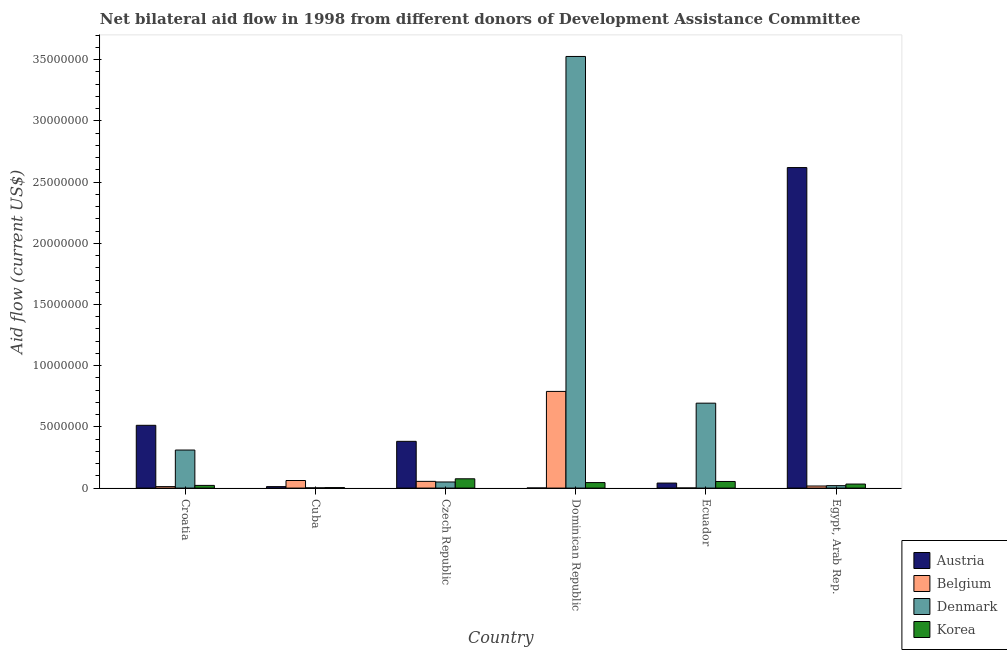Are the number of bars per tick equal to the number of legend labels?
Give a very brief answer. Yes. Are the number of bars on each tick of the X-axis equal?
Offer a very short reply. Yes. What is the label of the 2nd group of bars from the left?
Keep it short and to the point. Cuba. In how many cases, is the number of bars for a given country not equal to the number of legend labels?
Provide a succinct answer. 0. What is the amount of aid given by korea in Egypt, Arab Rep.?
Provide a short and direct response. 3.30e+05. Across all countries, what is the maximum amount of aid given by korea?
Give a very brief answer. 7.60e+05. Across all countries, what is the minimum amount of aid given by belgium?
Offer a terse response. 10000. In which country was the amount of aid given by belgium maximum?
Offer a very short reply. Dominican Republic. In which country was the amount of aid given by korea minimum?
Your response must be concise. Cuba. What is the total amount of aid given by denmark in the graph?
Offer a terse response. 4.60e+07. What is the difference between the amount of aid given by belgium in Ecuador and that in Egypt, Arab Rep.?
Offer a very short reply. -1.60e+05. What is the difference between the amount of aid given by denmark in Croatia and the amount of aid given by korea in Czech Republic?
Ensure brevity in your answer.  2.35e+06. What is the difference between the amount of aid given by korea and amount of aid given by belgium in Egypt, Arab Rep.?
Keep it short and to the point. 1.60e+05. In how many countries, is the amount of aid given by belgium greater than 25000000 US$?
Give a very brief answer. 0. What is the ratio of the amount of aid given by korea in Dominican Republic to that in Ecuador?
Provide a short and direct response. 0.83. Is the amount of aid given by korea in Czech Republic less than that in Dominican Republic?
Provide a succinct answer. No. Is the difference between the amount of aid given by korea in Croatia and Cuba greater than the difference between the amount of aid given by denmark in Croatia and Cuba?
Your answer should be compact. No. What is the difference between the highest and the lowest amount of aid given by korea?
Keep it short and to the point. 7.20e+05. Is it the case that in every country, the sum of the amount of aid given by denmark and amount of aid given by korea is greater than the sum of amount of aid given by austria and amount of aid given by belgium?
Offer a terse response. No. What does the 4th bar from the left in Dominican Republic represents?
Make the answer very short. Korea. Is it the case that in every country, the sum of the amount of aid given by austria and amount of aid given by belgium is greater than the amount of aid given by denmark?
Ensure brevity in your answer.  No. What is the difference between two consecutive major ticks on the Y-axis?
Your response must be concise. 5.00e+06. Does the graph contain any zero values?
Offer a very short reply. No. Where does the legend appear in the graph?
Make the answer very short. Bottom right. How many legend labels are there?
Your response must be concise. 4. What is the title of the graph?
Make the answer very short. Net bilateral aid flow in 1998 from different donors of Development Assistance Committee. What is the label or title of the X-axis?
Ensure brevity in your answer.  Country. What is the label or title of the Y-axis?
Ensure brevity in your answer.  Aid flow (current US$). What is the Aid flow (current US$) in Austria in Croatia?
Give a very brief answer. 5.13e+06. What is the Aid flow (current US$) in Denmark in Croatia?
Offer a very short reply. 3.11e+06. What is the Aid flow (current US$) of Korea in Croatia?
Provide a succinct answer. 2.20e+05. What is the Aid flow (current US$) of Austria in Cuba?
Offer a terse response. 1.20e+05. What is the Aid flow (current US$) of Belgium in Cuba?
Offer a very short reply. 6.20e+05. What is the Aid flow (current US$) in Denmark in Cuba?
Provide a succinct answer. 2.00e+04. What is the Aid flow (current US$) in Austria in Czech Republic?
Provide a succinct answer. 3.82e+06. What is the Aid flow (current US$) of Denmark in Czech Republic?
Offer a terse response. 5.00e+05. What is the Aid flow (current US$) in Korea in Czech Republic?
Offer a very short reply. 7.60e+05. What is the Aid flow (current US$) of Belgium in Dominican Republic?
Offer a very short reply. 7.90e+06. What is the Aid flow (current US$) of Denmark in Dominican Republic?
Keep it short and to the point. 3.53e+07. What is the Aid flow (current US$) of Austria in Ecuador?
Your answer should be very brief. 4.10e+05. What is the Aid flow (current US$) of Belgium in Ecuador?
Offer a terse response. 10000. What is the Aid flow (current US$) of Denmark in Ecuador?
Make the answer very short. 6.94e+06. What is the Aid flow (current US$) of Korea in Ecuador?
Keep it short and to the point. 5.40e+05. What is the Aid flow (current US$) in Austria in Egypt, Arab Rep.?
Your response must be concise. 2.62e+07. What is the Aid flow (current US$) in Belgium in Egypt, Arab Rep.?
Keep it short and to the point. 1.70e+05. What is the Aid flow (current US$) of Denmark in Egypt, Arab Rep.?
Offer a very short reply. 2.00e+05. What is the Aid flow (current US$) of Korea in Egypt, Arab Rep.?
Provide a succinct answer. 3.30e+05. Across all countries, what is the maximum Aid flow (current US$) in Austria?
Make the answer very short. 2.62e+07. Across all countries, what is the maximum Aid flow (current US$) of Belgium?
Offer a terse response. 7.90e+06. Across all countries, what is the maximum Aid flow (current US$) of Denmark?
Your answer should be compact. 3.53e+07. Across all countries, what is the maximum Aid flow (current US$) of Korea?
Your answer should be compact. 7.60e+05. Across all countries, what is the minimum Aid flow (current US$) of Denmark?
Offer a terse response. 2.00e+04. What is the total Aid flow (current US$) of Austria in the graph?
Your answer should be compact. 3.57e+07. What is the total Aid flow (current US$) of Belgium in the graph?
Provide a short and direct response. 9.37e+06. What is the total Aid flow (current US$) in Denmark in the graph?
Offer a very short reply. 4.60e+07. What is the total Aid flow (current US$) in Korea in the graph?
Offer a terse response. 2.34e+06. What is the difference between the Aid flow (current US$) of Austria in Croatia and that in Cuba?
Give a very brief answer. 5.01e+06. What is the difference between the Aid flow (current US$) in Belgium in Croatia and that in Cuba?
Give a very brief answer. -5.00e+05. What is the difference between the Aid flow (current US$) in Denmark in Croatia and that in Cuba?
Keep it short and to the point. 3.09e+06. What is the difference between the Aid flow (current US$) of Austria in Croatia and that in Czech Republic?
Your answer should be compact. 1.31e+06. What is the difference between the Aid flow (current US$) of Belgium in Croatia and that in Czech Republic?
Your response must be concise. -4.30e+05. What is the difference between the Aid flow (current US$) in Denmark in Croatia and that in Czech Republic?
Offer a terse response. 2.61e+06. What is the difference between the Aid flow (current US$) in Korea in Croatia and that in Czech Republic?
Provide a short and direct response. -5.40e+05. What is the difference between the Aid flow (current US$) of Austria in Croatia and that in Dominican Republic?
Ensure brevity in your answer.  5.12e+06. What is the difference between the Aid flow (current US$) of Belgium in Croatia and that in Dominican Republic?
Offer a terse response. -7.78e+06. What is the difference between the Aid flow (current US$) of Denmark in Croatia and that in Dominican Republic?
Keep it short and to the point. -3.22e+07. What is the difference between the Aid flow (current US$) of Austria in Croatia and that in Ecuador?
Your answer should be compact. 4.72e+06. What is the difference between the Aid flow (current US$) of Belgium in Croatia and that in Ecuador?
Provide a short and direct response. 1.10e+05. What is the difference between the Aid flow (current US$) of Denmark in Croatia and that in Ecuador?
Keep it short and to the point. -3.83e+06. What is the difference between the Aid flow (current US$) in Korea in Croatia and that in Ecuador?
Keep it short and to the point. -3.20e+05. What is the difference between the Aid flow (current US$) of Austria in Croatia and that in Egypt, Arab Rep.?
Your answer should be very brief. -2.11e+07. What is the difference between the Aid flow (current US$) of Belgium in Croatia and that in Egypt, Arab Rep.?
Provide a short and direct response. -5.00e+04. What is the difference between the Aid flow (current US$) of Denmark in Croatia and that in Egypt, Arab Rep.?
Ensure brevity in your answer.  2.91e+06. What is the difference between the Aid flow (current US$) in Austria in Cuba and that in Czech Republic?
Make the answer very short. -3.70e+06. What is the difference between the Aid flow (current US$) in Denmark in Cuba and that in Czech Republic?
Ensure brevity in your answer.  -4.80e+05. What is the difference between the Aid flow (current US$) of Korea in Cuba and that in Czech Republic?
Your answer should be very brief. -7.20e+05. What is the difference between the Aid flow (current US$) in Austria in Cuba and that in Dominican Republic?
Ensure brevity in your answer.  1.10e+05. What is the difference between the Aid flow (current US$) of Belgium in Cuba and that in Dominican Republic?
Ensure brevity in your answer.  -7.28e+06. What is the difference between the Aid flow (current US$) in Denmark in Cuba and that in Dominican Republic?
Ensure brevity in your answer.  -3.52e+07. What is the difference between the Aid flow (current US$) in Korea in Cuba and that in Dominican Republic?
Provide a succinct answer. -4.10e+05. What is the difference between the Aid flow (current US$) in Austria in Cuba and that in Ecuador?
Give a very brief answer. -2.90e+05. What is the difference between the Aid flow (current US$) of Belgium in Cuba and that in Ecuador?
Offer a very short reply. 6.10e+05. What is the difference between the Aid flow (current US$) of Denmark in Cuba and that in Ecuador?
Make the answer very short. -6.92e+06. What is the difference between the Aid flow (current US$) of Korea in Cuba and that in Ecuador?
Provide a succinct answer. -5.00e+05. What is the difference between the Aid flow (current US$) of Austria in Cuba and that in Egypt, Arab Rep.?
Provide a short and direct response. -2.61e+07. What is the difference between the Aid flow (current US$) of Belgium in Cuba and that in Egypt, Arab Rep.?
Provide a short and direct response. 4.50e+05. What is the difference between the Aid flow (current US$) of Denmark in Cuba and that in Egypt, Arab Rep.?
Provide a short and direct response. -1.80e+05. What is the difference between the Aid flow (current US$) of Austria in Czech Republic and that in Dominican Republic?
Ensure brevity in your answer.  3.81e+06. What is the difference between the Aid flow (current US$) of Belgium in Czech Republic and that in Dominican Republic?
Your answer should be compact. -7.35e+06. What is the difference between the Aid flow (current US$) in Denmark in Czech Republic and that in Dominican Republic?
Provide a short and direct response. -3.48e+07. What is the difference between the Aid flow (current US$) in Korea in Czech Republic and that in Dominican Republic?
Your answer should be very brief. 3.10e+05. What is the difference between the Aid flow (current US$) in Austria in Czech Republic and that in Ecuador?
Your answer should be compact. 3.41e+06. What is the difference between the Aid flow (current US$) of Belgium in Czech Republic and that in Ecuador?
Give a very brief answer. 5.40e+05. What is the difference between the Aid flow (current US$) of Denmark in Czech Republic and that in Ecuador?
Ensure brevity in your answer.  -6.44e+06. What is the difference between the Aid flow (current US$) in Korea in Czech Republic and that in Ecuador?
Your answer should be very brief. 2.20e+05. What is the difference between the Aid flow (current US$) of Austria in Czech Republic and that in Egypt, Arab Rep.?
Provide a succinct answer. -2.24e+07. What is the difference between the Aid flow (current US$) of Belgium in Czech Republic and that in Egypt, Arab Rep.?
Keep it short and to the point. 3.80e+05. What is the difference between the Aid flow (current US$) of Austria in Dominican Republic and that in Ecuador?
Your response must be concise. -4.00e+05. What is the difference between the Aid flow (current US$) in Belgium in Dominican Republic and that in Ecuador?
Keep it short and to the point. 7.89e+06. What is the difference between the Aid flow (current US$) of Denmark in Dominican Republic and that in Ecuador?
Ensure brevity in your answer.  2.83e+07. What is the difference between the Aid flow (current US$) in Korea in Dominican Republic and that in Ecuador?
Your answer should be very brief. -9.00e+04. What is the difference between the Aid flow (current US$) of Austria in Dominican Republic and that in Egypt, Arab Rep.?
Your answer should be very brief. -2.62e+07. What is the difference between the Aid flow (current US$) of Belgium in Dominican Republic and that in Egypt, Arab Rep.?
Your answer should be compact. 7.73e+06. What is the difference between the Aid flow (current US$) of Denmark in Dominican Republic and that in Egypt, Arab Rep.?
Offer a terse response. 3.51e+07. What is the difference between the Aid flow (current US$) in Austria in Ecuador and that in Egypt, Arab Rep.?
Provide a short and direct response. -2.58e+07. What is the difference between the Aid flow (current US$) of Denmark in Ecuador and that in Egypt, Arab Rep.?
Ensure brevity in your answer.  6.74e+06. What is the difference between the Aid flow (current US$) of Austria in Croatia and the Aid flow (current US$) of Belgium in Cuba?
Your response must be concise. 4.51e+06. What is the difference between the Aid flow (current US$) in Austria in Croatia and the Aid flow (current US$) in Denmark in Cuba?
Your answer should be very brief. 5.11e+06. What is the difference between the Aid flow (current US$) of Austria in Croatia and the Aid flow (current US$) of Korea in Cuba?
Provide a succinct answer. 5.09e+06. What is the difference between the Aid flow (current US$) in Belgium in Croatia and the Aid flow (current US$) in Denmark in Cuba?
Make the answer very short. 1.00e+05. What is the difference between the Aid flow (current US$) of Denmark in Croatia and the Aid flow (current US$) of Korea in Cuba?
Keep it short and to the point. 3.07e+06. What is the difference between the Aid flow (current US$) in Austria in Croatia and the Aid flow (current US$) in Belgium in Czech Republic?
Give a very brief answer. 4.58e+06. What is the difference between the Aid flow (current US$) of Austria in Croatia and the Aid flow (current US$) of Denmark in Czech Republic?
Ensure brevity in your answer.  4.63e+06. What is the difference between the Aid flow (current US$) of Austria in Croatia and the Aid flow (current US$) of Korea in Czech Republic?
Your answer should be very brief. 4.37e+06. What is the difference between the Aid flow (current US$) in Belgium in Croatia and the Aid flow (current US$) in Denmark in Czech Republic?
Ensure brevity in your answer.  -3.80e+05. What is the difference between the Aid flow (current US$) in Belgium in Croatia and the Aid flow (current US$) in Korea in Czech Republic?
Offer a terse response. -6.40e+05. What is the difference between the Aid flow (current US$) of Denmark in Croatia and the Aid flow (current US$) of Korea in Czech Republic?
Ensure brevity in your answer.  2.35e+06. What is the difference between the Aid flow (current US$) of Austria in Croatia and the Aid flow (current US$) of Belgium in Dominican Republic?
Your answer should be compact. -2.77e+06. What is the difference between the Aid flow (current US$) in Austria in Croatia and the Aid flow (current US$) in Denmark in Dominican Republic?
Provide a succinct answer. -3.01e+07. What is the difference between the Aid flow (current US$) in Austria in Croatia and the Aid flow (current US$) in Korea in Dominican Republic?
Offer a terse response. 4.68e+06. What is the difference between the Aid flow (current US$) of Belgium in Croatia and the Aid flow (current US$) of Denmark in Dominican Republic?
Offer a terse response. -3.52e+07. What is the difference between the Aid flow (current US$) of Belgium in Croatia and the Aid flow (current US$) of Korea in Dominican Republic?
Provide a succinct answer. -3.30e+05. What is the difference between the Aid flow (current US$) in Denmark in Croatia and the Aid flow (current US$) in Korea in Dominican Republic?
Provide a succinct answer. 2.66e+06. What is the difference between the Aid flow (current US$) in Austria in Croatia and the Aid flow (current US$) in Belgium in Ecuador?
Provide a short and direct response. 5.12e+06. What is the difference between the Aid flow (current US$) in Austria in Croatia and the Aid flow (current US$) in Denmark in Ecuador?
Your answer should be very brief. -1.81e+06. What is the difference between the Aid flow (current US$) of Austria in Croatia and the Aid flow (current US$) of Korea in Ecuador?
Your answer should be very brief. 4.59e+06. What is the difference between the Aid flow (current US$) in Belgium in Croatia and the Aid flow (current US$) in Denmark in Ecuador?
Provide a succinct answer. -6.82e+06. What is the difference between the Aid flow (current US$) in Belgium in Croatia and the Aid flow (current US$) in Korea in Ecuador?
Offer a terse response. -4.20e+05. What is the difference between the Aid flow (current US$) of Denmark in Croatia and the Aid flow (current US$) of Korea in Ecuador?
Ensure brevity in your answer.  2.57e+06. What is the difference between the Aid flow (current US$) in Austria in Croatia and the Aid flow (current US$) in Belgium in Egypt, Arab Rep.?
Ensure brevity in your answer.  4.96e+06. What is the difference between the Aid flow (current US$) of Austria in Croatia and the Aid flow (current US$) of Denmark in Egypt, Arab Rep.?
Your answer should be compact. 4.93e+06. What is the difference between the Aid flow (current US$) of Austria in Croatia and the Aid flow (current US$) of Korea in Egypt, Arab Rep.?
Ensure brevity in your answer.  4.80e+06. What is the difference between the Aid flow (current US$) in Belgium in Croatia and the Aid flow (current US$) in Korea in Egypt, Arab Rep.?
Offer a very short reply. -2.10e+05. What is the difference between the Aid flow (current US$) of Denmark in Croatia and the Aid flow (current US$) of Korea in Egypt, Arab Rep.?
Offer a terse response. 2.78e+06. What is the difference between the Aid flow (current US$) of Austria in Cuba and the Aid flow (current US$) of Belgium in Czech Republic?
Your answer should be very brief. -4.30e+05. What is the difference between the Aid flow (current US$) of Austria in Cuba and the Aid flow (current US$) of Denmark in Czech Republic?
Provide a short and direct response. -3.80e+05. What is the difference between the Aid flow (current US$) of Austria in Cuba and the Aid flow (current US$) of Korea in Czech Republic?
Ensure brevity in your answer.  -6.40e+05. What is the difference between the Aid flow (current US$) of Belgium in Cuba and the Aid flow (current US$) of Denmark in Czech Republic?
Offer a very short reply. 1.20e+05. What is the difference between the Aid flow (current US$) of Belgium in Cuba and the Aid flow (current US$) of Korea in Czech Republic?
Ensure brevity in your answer.  -1.40e+05. What is the difference between the Aid flow (current US$) in Denmark in Cuba and the Aid flow (current US$) in Korea in Czech Republic?
Provide a succinct answer. -7.40e+05. What is the difference between the Aid flow (current US$) of Austria in Cuba and the Aid flow (current US$) of Belgium in Dominican Republic?
Offer a very short reply. -7.78e+06. What is the difference between the Aid flow (current US$) in Austria in Cuba and the Aid flow (current US$) in Denmark in Dominican Republic?
Provide a succinct answer. -3.52e+07. What is the difference between the Aid flow (current US$) of Austria in Cuba and the Aid flow (current US$) of Korea in Dominican Republic?
Offer a very short reply. -3.30e+05. What is the difference between the Aid flow (current US$) of Belgium in Cuba and the Aid flow (current US$) of Denmark in Dominican Republic?
Provide a succinct answer. -3.46e+07. What is the difference between the Aid flow (current US$) in Denmark in Cuba and the Aid flow (current US$) in Korea in Dominican Republic?
Keep it short and to the point. -4.30e+05. What is the difference between the Aid flow (current US$) in Austria in Cuba and the Aid flow (current US$) in Denmark in Ecuador?
Make the answer very short. -6.82e+06. What is the difference between the Aid flow (current US$) in Austria in Cuba and the Aid flow (current US$) in Korea in Ecuador?
Offer a terse response. -4.20e+05. What is the difference between the Aid flow (current US$) in Belgium in Cuba and the Aid flow (current US$) in Denmark in Ecuador?
Make the answer very short. -6.32e+06. What is the difference between the Aid flow (current US$) in Denmark in Cuba and the Aid flow (current US$) in Korea in Ecuador?
Make the answer very short. -5.20e+05. What is the difference between the Aid flow (current US$) of Austria in Cuba and the Aid flow (current US$) of Belgium in Egypt, Arab Rep.?
Your answer should be very brief. -5.00e+04. What is the difference between the Aid flow (current US$) of Austria in Cuba and the Aid flow (current US$) of Korea in Egypt, Arab Rep.?
Provide a succinct answer. -2.10e+05. What is the difference between the Aid flow (current US$) of Belgium in Cuba and the Aid flow (current US$) of Denmark in Egypt, Arab Rep.?
Keep it short and to the point. 4.20e+05. What is the difference between the Aid flow (current US$) of Denmark in Cuba and the Aid flow (current US$) of Korea in Egypt, Arab Rep.?
Make the answer very short. -3.10e+05. What is the difference between the Aid flow (current US$) of Austria in Czech Republic and the Aid flow (current US$) of Belgium in Dominican Republic?
Offer a terse response. -4.08e+06. What is the difference between the Aid flow (current US$) in Austria in Czech Republic and the Aid flow (current US$) in Denmark in Dominican Republic?
Your answer should be very brief. -3.14e+07. What is the difference between the Aid flow (current US$) of Austria in Czech Republic and the Aid flow (current US$) of Korea in Dominican Republic?
Make the answer very short. 3.37e+06. What is the difference between the Aid flow (current US$) of Belgium in Czech Republic and the Aid flow (current US$) of Denmark in Dominican Republic?
Ensure brevity in your answer.  -3.47e+07. What is the difference between the Aid flow (current US$) in Belgium in Czech Republic and the Aid flow (current US$) in Korea in Dominican Republic?
Ensure brevity in your answer.  1.00e+05. What is the difference between the Aid flow (current US$) in Denmark in Czech Republic and the Aid flow (current US$) in Korea in Dominican Republic?
Your answer should be very brief. 5.00e+04. What is the difference between the Aid flow (current US$) in Austria in Czech Republic and the Aid flow (current US$) in Belgium in Ecuador?
Your answer should be compact. 3.81e+06. What is the difference between the Aid flow (current US$) of Austria in Czech Republic and the Aid flow (current US$) of Denmark in Ecuador?
Offer a terse response. -3.12e+06. What is the difference between the Aid flow (current US$) in Austria in Czech Republic and the Aid flow (current US$) in Korea in Ecuador?
Provide a succinct answer. 3.28e+06. What is the difference between the Aid flow (current US$) in Belgium in Czech Republic and the Aid flow (current US$) in Denmark in Ecuador?
Offer a terse response. -6.39e+06. What is the difference between the Aid flow (current US$) of Austria in Czech Republic and the Aid flow (current US$) of Belgium in Egypt, Arab Rep.?
Offer a very short reply. 3.65e+06. What is the difference between the Aid flow (current US$) in Austria in Czech Republic and the Aid flow (current US$) in Denmark in Egypt, Arab Rep.?
Your answer should be compact. 3.62e+06. What is the difference between the Aid flow (current US$) in Austria in Czech Republic and the Aid flow (current US$) in Korea in Egypt, Arab Rep.?
Your answer should be compact. 3.49e+06. What is the difference between the Aid flow (current US$) in Belgium in Czech Republic and the Aid flow (current US$) in Denmark in Egypt, Arab Rep.?
Your answer should be very brief. 3.50e+05. What is the difference between the Aid flow (current US$) of Denmark in Czech Republic and the Aid flow (current US$) of Korea in Egypt, Arab Rep.?
Your answer should be compact. 1.70e+05. What is the difference between the Aid flow (current US$) in Austria in Dominican Republic and the Aid flow (current US$) in Denmark in Ecuador?
Your response must be concise. -6.93e+06. What is the difference between the Aid flow (current US$) of Austria in Dominican Republic and the Aid flow (current US$) of Korea in Ecuador?
Offer a very short reply. -5.30e+05. What is the difference between the Aid flow (current US$) of Belgium in Dominican Republic and the Aid flow (current US$) of Denmark in Ecuador?
Give a very brief answer. 9.60e+05. What is the difference between the Aid flow (current US$) of Belgium in Dominican Republic and the Aid flow (current US$) of Korea in Ecuador?
Provide a succinct answer. 7.36e+06. What is the difference between the Aid flow (current US$) in Denmark in Dominican Republic and the Aid flow (current US$) in Korea in Ecuador?
Make the answer very short. 3.47e+07. What is the difference between the Aid flow (current US$) in Austria in Dominican Republic and the Aid flow (current US$) in Belgium in Egypt, Arab Rep.?
Keep it short and to the point. -1.60e+05. What is the difference between the Aid flow (current US$) of Austria in Dominican Republic and the Aid flow (current US$) of Korea in Egypt, Arab Rep.?
Your response must be concise. -3.20e+05. What is the difference between the Aid flow (current US$) of Belgium in Dominican Republic and the Aid flow (current US$) of Denmark in Egypt, Arab Rep.?
Provide a short and direct response. 7.70e+06. What is the difference between the Aid flow (current US$) of Belgium in Dominican Republic and the Aid flow (current US$) of Korea in Egypt, Arab Rep.?
Provide a succinct answer. 7.57e+06. What is the difference between the Aid flow (current US$) of Denmark in Dominican Republic and the Aid flow (current US$) of Korea in Egypt, Arab Rep.?
Give a very brief answer. 3.49e+07. What is the difference between the Aid flow (current US$) in Austria in Ecuador and the Aid flow (current US$) in Denmark in Egypt, Arab Rep.?
Offer a terse response. 2.10e+05. What is the difference between the Aid flow (current US$) in Belgium in Ecuador and the Aid flow (current US$) in Denmark in Egypt, Arab Rep.?
Provide a succinct answer. -1.90e+05. What is the difference between the Aid flow (current US$) of Belgium in Ecuador and the Aid flow (current US$) of Korea in Egypt, Arab Rep.?
Keep it short and to the point. -3.20e+05. What is the difference between the Aid flow (current US$) in Denmark in Ecuador and the Aid flow (current US$) in Korea in Egypt, Arab Rep.?
Provide a succinct answer. 6.61e+06. What is the average Aid flow (current US$) in Austria per country?
Make the answer very short. 5.95e+06. What is the average Aid flow (current US$) in Belgium per country?
Provide a short and direct response. 1.56e+06. What is the average Aid flow (current US$) in Denmark per country?
Offer a very short reply. 7.67e+06. What is the difference between the Aid flow (current US$) of Austria and Aid flow (current US$) of Belgium in Croatia?
Provide a short and direct response. 5.01e+06. What is the difference between the Aid flow (current US$) in Austria and Aid flow (current US$) in Denmark in Croatia?
Make the answer very short. 2.02e+06. What is the difference between the Aid flow (current US$) of Austria and Aid flow (current US$) of Korea in Croatia?
Ensure brevity in your answer.  4.91e+06. What is the difference between the Aid flow (current US$) of Belgium and Aid flow (current US$) of Denmark in Croatia?
Make the answer very short. -2.99e+06. What is the difference between the Aid flow (current US$) in Denmark and Aid flow (current US$) in Korea in Croatia?
Make the answer very short. 2.89e+06. What is the difference between the Aid flow (current US$) of Austria and Aid flow (current US$) of Belgium in Cuba?
Keep it short and to the point. -5.00e+05. What is the difference between the Aid flow (current US$) in Austria and Aid flow (current US$) in Denmark in Cuba?
Your answer should be very brief. 1.00e+05. What is the difference between the Aid flow (current US$) in Austria and Aid flow (current US$) in Korea in Cuba?
Make the answer very short. 8.00e+04. What is the difference between the Aid flow (current US$) of Belgium and Aid flow (current US$) of Denmark in Cuba?
Offer a very short reply. 6.00e+05. What is the difference between the Aid flow (current US$) of Belgium and Aid flow (current US$) of Korea in Cuba?
Ensure brevity in your answer.  5.80e+05. What is the difference between the Aid flow (current US$) in Austria and Aid flow (current US$) in Belgium in Czech Republic?
Ensure brevity in your answer.  3.27e+06. What is the difference between the Aid flow (current US$) of Austria and Aid flow (current US$) of Denmark in Czech Republic?
Your response must be concise. 3.32e+06. What is the difference between the Aid flow (current US$) in Austria and Aid flow (current US$) in Korea in Czech Republic?
Ensure brevity in your answer.  3.06e+06. What is the difference between the Aid flow (current US$) in Belgium and Aid flow (current US$) in Denmark in Czech Republic?
Give a very brief answer. 5.00e+04. What is the difference between the Aid flow (current US$) in Belgium and Aid flow (current US$) in Korea in Czech Republic?
Give a very brief answer. -2.10e+05. What is the difference between the Aid flow (current US$) of Denmark and Aid flow (current US$) of Korea in Czech Republic?
Your answer should be compact. -2.60e+05. What is the difference between the Aid flow (current US$) of Austria and Aid flow (current US$) of Belgium in Dominican Republic?
Offer a very short reply. -7.89e+06. What is the difference between the Aid flow (current US$) in Austria and Aid flow (current US$) in Denmark in Dominican Republic?
Ensure brevity in your answer.  -3.53e+07. What is the difference between the Aid flow (current US$) of Austria and Aid flow (current US$) of Korea in Dominican Republic?
Offer a very short reply. -4.40e+05. What is the difference between the Aid flow (current US$) in Belgium and Aid flow (current US$) in Denmark in Dominican Republic?
Keep it short and to the point. -2.74e+07. What is the difference between the Aid flow (current US$) of Belgium and Aid flow (current US$) of Korea in Dominican Republic?
Give a very brief answer. 7.45e+06. What is the difference between the Aid flow (current US$) of Denmark and Aid flow (current US$) of Korea in Dominican Republic?
Offer a terse response. 3.48e+07. What is the difference between the Aid flow (current US$) in Austria and Aid flow (current US$) in Denmark in Ecuador?
Your answer should be very brief. -6.53e+06. What is the difference between the Aid flow (current US$) in Austria and Aid flow (current US$) in Korea in Ecuador?
Provide a short and direct response. -1.30e+05. What is the difference between the Aid flow (current US$) of Belgium and Aid flow (current US$) of Denmark in Ecuador?
Provide a short and direct response. -6.93e+06. What is the difference between the Aid flow (current US$) in Belgium and Aid flow (current US$) in Korea in Ecuador?
Give a very brief answer. -5.30e+05. What is the difference between the Aid flow (current US$) in Denmark and Aid flow (current US$) in Korea in Ecuador?
Offer a terse response. 6.40e+06. What is the difference between the Aid flow (current US$) in Austria and Aid flow (current US$) in Belgium in Egypt, Arab Rep.?
Offer a very short reply. 2.60e+07. What is the difference between the Aid flow (current US$) of Austria and Aid flow (current US$) of Denmark in Egypt, Arab Rep.?
Ensure brevity in your answer.  2.60e+07. What is the difference between the Aid flow (current US$) in Austria and Aid flow (current US$) in Korea in Egypt, Arab Rep.?
Provide a short and direct response. 2.59e+07. What is the difference between the Aid flow (current US$) of Belgium and Aid flow (current US$) of Denmark in Egypt, Arab Rep.?
Offer a terse response. -3.00e+04. What is the difference between the Aid flow (current US$) in Belgium and Aid flow (current US$) in Korea in Egypt, Arab Rep.?
Give a very brief answer. -1.60e+05. What is the difference between the Aid flow (current US$) of Denmark and Aid flow (current US$) of Korea in Egypt, Arab Rep.?
Your answer should be compact. -1.30e+05. What is the ratio of the Aid flow (current US$) in Austria in Croatia to that in Cuba?
Your answer should be very brief. 42.75. What is the ratio of the Aid flow (current US$) of Belgium in Croatia to that in Cuba?
Provide a succinct answer. 0.19. What is the ratio of the Aid flow (current US$) of Denmark in Croatia to that in Cuba?
Provide a succinct answer. 155.5. What is the ratio of the Aid flow (current US$) of Korea in Croatia to that in Cuba?
Keep it short and to the point. 5.5. What is the ratio of the Aid flow (current US$) of Austria in Croatia to that in Czech Republic?
Your response must be concise. 1.34. What is the ratio of the Aid flow (current US$) in Belgium in Croatia to that in Czech Republic?
Ensure brevity in your answer.  0.22. What is the ratio of the Aid flow (current US$) of Denmark in Croatia to that in Czech Republic?
Your response must be concise. 6.22. What is the ratio of the Aid flow (current US$) in Korea in Croatia to that in Czech Republic?
Your answer should be compact. 0.29. What is the ratio of the Aid flow (current US$) in Austria in Croatia to that in Dominican Republic?
Offer a terse response. 513. What is the ratio of the Aid flow (current US$) in Belgium in Croatia to that in Dominican Republic?
Offer a very short reply. 0.02. What is the ratio of the Aid flow (current US$) of Denmark in Croatia to that in Dominican Republic?
Offer a terse response. 0.09. What is the ratio of the Aid flow (current US$) of Korea in Croatia to that in Dominican Republic?
Provide a short and direct response. 0.49. What is the ratio of the Aid flow (current US$) in Austria in Croatia to that in Ecuador?
Your answer should be compact. 12.51. What is the ratio of the Aid flow (current US$) in Denmark in Croatia to that in Ecuador?
Your answer should be very brief. 0.45. What is the ratio of the Aid flow (current US$) of Korea in Croatia to that in Ecuador?
Make the answer very short. 0.41. What is the ratio of the Aid flow (current US$) in Austria in Croatia to that in Egypt, Arab Rep.?
Offer a terse response. 0.2. What is the ratio of the Aid flow (current US$) of Belgium in Croatia to that in Egypt, Arab Rep.?
Give a very brief answer. 0.71. What is the ratio of the Aid flow (current US$) in Denmark in Croatia to that in Egypt, Arab Rep.?
Your response must be concise. 15.55. What is the ratio of the Aid flow (current US$) of Korea in Croatia to that in Egypt, Arab Rep.?
Give a very brief answer. 0.67. What is the ratio of the Aid flow (current US$) in Austria in Cuba to that in Czech Republic?
Offer a terse response. 0.03. What is the ratio of the Aid flow (current US$) of Belgium in Cuba to that in Czech Republic?
Offer a terse response. 1.13. What is the ratio of the Aid flow (current US$) in Korea in Cuba to that in Czech Republic?
Ensure brevity in your answer.  0.05. What is the ratio of the Aid flow (current US$) in Austria in Cuba to that in Dominican Republic?
Your answer should be very brief. 12. What is the ratio of the Aid flow (current US$) in Belgium in Cuba to that in Dominican Republic?
Your response must be concise. 0.08. What is the ratio of the Aid flow (current US$) in Denmark in Cuba to that in Dominican Republic?
Provide a succinct answer. 0. What is the ratio of the Aid flow (current US$) of Korea in Cuba to that in Dominican Republic?
Offer a very short reply. 0.09. What is the ratio of the Aid flow (current US$) in Austria in Cuba to that in Ecuador?
Keep it short and to the point. 0.29. What is the ratio of the Aid flow (current US$) of Belgium in Cuba to that in Ecuador?
Provide a short and direct response. 62. What is the ratio of the Aid flow (current US$) in Denmark in Cuba to that in Ecuador?
Give a very brief answer. 0. What is the ratio of the Aid flow (current US$) of Korea in Cuba to that in Ecuador?
Offer a very short reply. 0.07. What is the ratio of the Aid flow (current US$) of Austria in Cuba to that in Egypt, Arab Rep.?
Your answer should be very brief. 0. What is the ratio of the Aid flow (current US$) of Belgium in Cuba to that in Egypt, Arab Rep.?
Offer a terse response. 3.65. What is the ratio of the Aid flow (current US$) of Korea in Cuba to that in Egypt, Arab Rep.?
Keep it short and to the point. 0.12. What is the ratio of the Aid flow (current US$) of Austria in Czech Republic to that in Dominican Republic?
Ensure brevity in your answer.  382. What is the ratio of the Aid flow (current US$) in Belgium in Czech Republic to that in Dominican Republic?
Keep it short and to the point. 0.07. What is the ratio of the Aid flow (current US$) in Denmark in Czech Republic to that in Dominican Republic?
Offer a terse response. 0.01. What is the ratio of the Aid flow (current US$) in Korea in Czech Republic to that in Dominican Republic?
Your response must be concise. 1.69. What is the ratio of the Aid flow (current US$) of Austria in Czech Republic to that in Ecuador?
Ensure brevity in your answer.  9.32. What is the ratio of the Aid flow (current US$) in Belgium in Czech Republic to that in Ecuador?
Your answer should be compact. 55. What is the ratio of the Aid flow (current US$) of Denmark in Czech Republic to that in Ecuador?
Make the answer very short. 0.07. What is the ratio of the Aid flow (current US$) of Korea in Czech Republic to that in Ecuador?
Your answer should be compact. 1.41. What is the ratio of the Aid flow (current US$) in Austria in Czech Republic to that in Egypt, Arab Rep.?
Provide a succinct answer. 0.15. What is the ratio of the Aid flow (current US$) of Belgium in Czech Republic to that in Egypt, Arab Rep.?
Make the answer very short. 3.24. What is the ratio of the Aid flow (current US$) in Denmark in Czech Republic to that in Egypt, Arab Rep.?
Keep it short and to the point. 2.5. What is the ratio of the Aid flow (current US$) of Korea in Czech Republic to that in Egypt, Arab Rep.?
Provide a succinct answer. 2.3. What is the ratio of the Aid flow (current US$) of Austria in Dominican Republic to that in Ecuador?
Your response must be concise. 0.02. What is the ratio of the Aid flow (current US$) of Belgium in Dominican Republic to that in Ecuador?
Offer a very short reply. 790. What is the ratio of the Aid flow (current US$) in Denmark in Dominican Republic to that in Ecuador?
Offer a terse response. 5.08. What is the ratio of the Aid flow (current US$) of Korea in Dominican Republic to that in Ecuador?
Your response must be concise. 0.83. What is the ratio of the Aid flow (current US$) of Austria in Dominican Republic to that in Egypt, Arab Rep.?
Keep it short and to the point. 0. What is the ratio of the Aid flow (current US$) in Belgium in Dominican Republic to that in Egypt, Arab Rep.?
Offer a very short reply. 46.47. What is the ratio of the Aid flow (current US$) in Denmark in Dominican Republic to that in Egypt, Arab Rep.?
Provide a succinct answer. 176.35. What is the ratio of the Aid flow (current US$) in Korea in Dominican Republic to that in Egypt, Arab Rep.?
Keep it short and to the point. 1.36. What is the ratio of the Aid flow (current US$) of Austria in Ecuador to that in Egypt, Arab Rep.?
Ensure brevity in your answer.  0.02. What is the ratio of the Aid flow (current US$) in Belgium in Ecuador to that in Egypt, Arab Rep.?
Give a very brief answer. 0.06. What is the ratio of the Aid flow (current US$) in Denmark in Ecuador to that in Egypt, Arab Rep.?
Give a very brief answer. 34.7. What is the ratio of the Aid flow (current US$) in Korea in Ecuador to that in Egypt, Arab Rep.?
Provide a succinct answer. 1.64. What is the difference between the highest and the second highest Aid flow (current US$) in Austria?
Your answer should be compact. 2.11e+07. What is the difference between the highest and the second highest Aid flow (current US$) in Belgium?
Ensure brevity in your answer.  7.28e+06. What is the difference between the highest and the second highest Aid flow (current US$) of Denmark?
Ensure brevity in your answer.  2.83e+07. What is the difference between the highest and the lowest Aid flow (current US$) in Austria?
Keep it short and to the point. 2.62e+07. What is the difference between the highest and the lowest Aid flow (current US$) of Belgium?
Your response must be concise. 7.89e+06. What is the difference between the highest and the lowest Aid flow (current US$) in Denmark?
Provide a short and direct response. 3.52e+07. What is the difference between the highest and the lowest Aid flow (current US$) in Korea?
Your answer should be compact. 7.20e+05. 